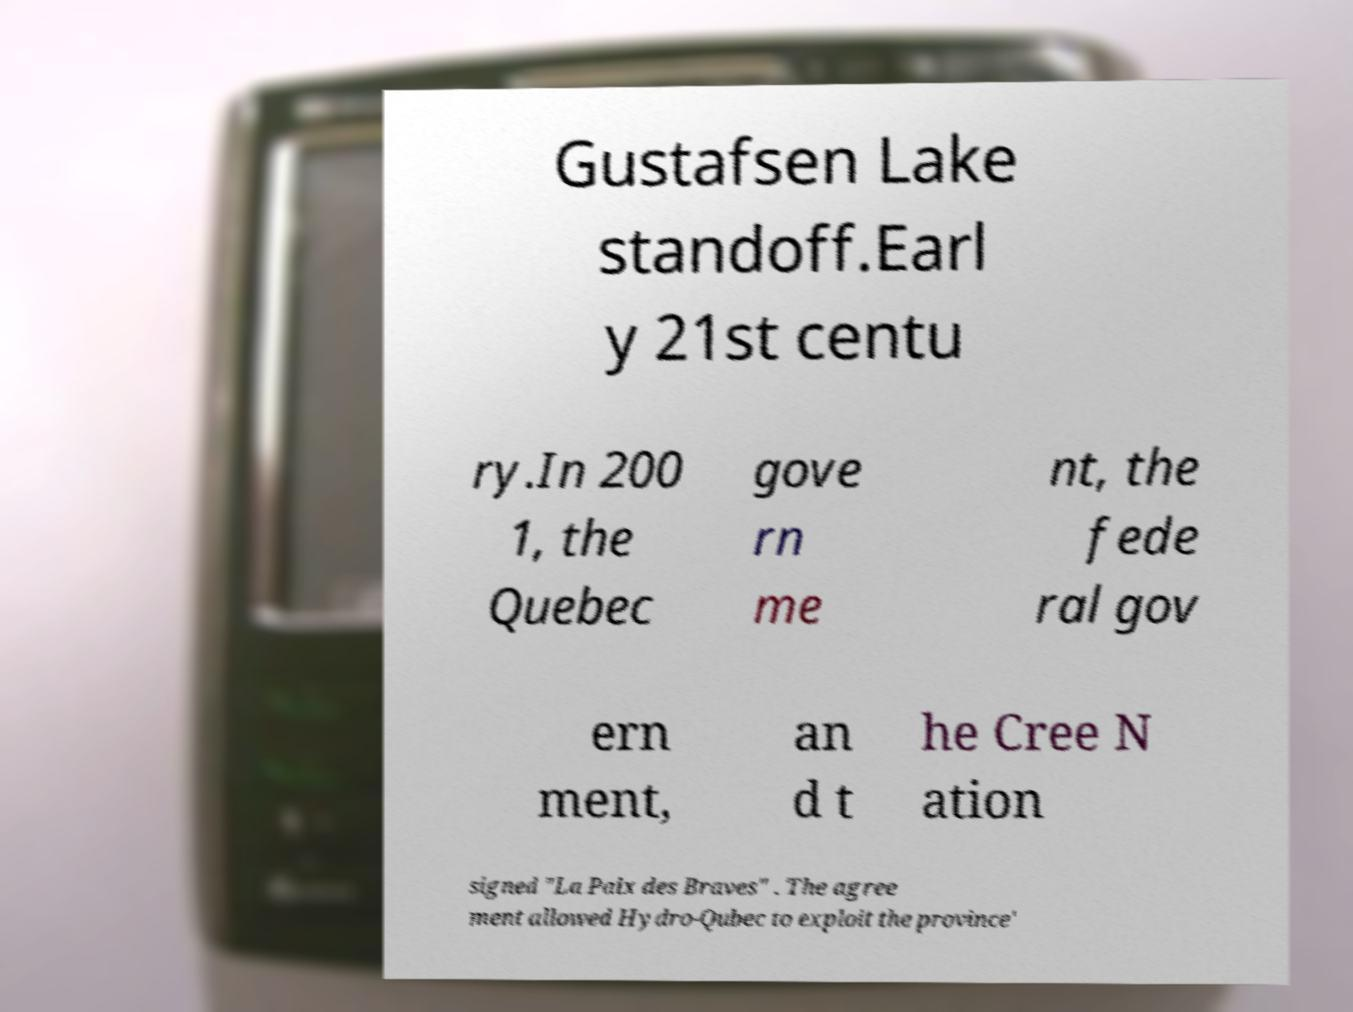Could you assist in decoding the text presented in this image and type it out clearly? Gustafsen Lake standoff.Earl y 21st centu ry.In 200 1, the Quebec gove rn me nt, the fede ral gov ern ment, an d t he Cree N ation signed "La Paix des Braves" . The agree ment allowed Hydro-Qubec to exploit the province' 